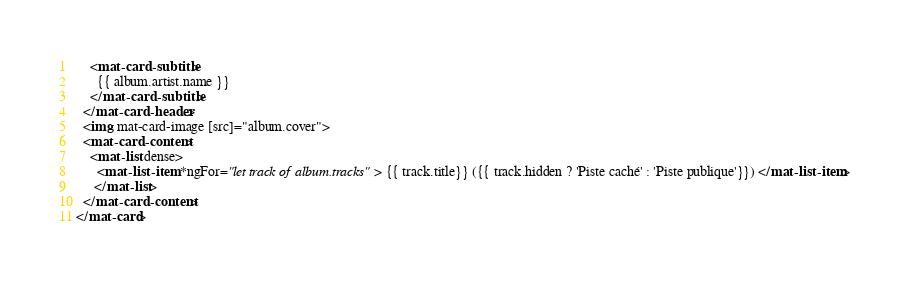<code> <loc_0><loc_0><loc_500><loc_500><_HTML_>    <mat-card-subtitle>
      {{ album.artist.name }}
    </mat-card-subtitle>
  </mat-card-header>
  <img mat-card-image [src]="album.cover">
  <mat-card-content>
    <mat-list dense>
      <mat-list-item *ngFor="let track of album.tracks"> {{ track.title}} ({{ track.hidden ? 'Piste caché' : 'Piste publique'}}) </mat-list-item>
     </mat-list>
  </mat-card-content>
</mat-card></code> 